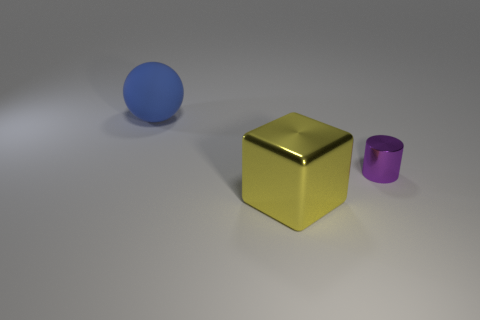What is the material of the big thing that is on the right side of the blue matte sphere?
Your answer should be very brief. Metal. There is a object that is behind the metallic cube and in front of the matte ball; what shape is it?
Your answer should be very brief. Cylinder. What material is the large yellow object?
Provide a succinct answer. Metal. What number of cylinders are either matte things or big red objects?
Offer a terse response. 0. Do the large yellow block and the blue thing have the same material?
Offer a very short reply. No. What is the thing that is both to the left of the tiny cylinder and in front of the large blue thing made of?
Ensure brevity in your answer.  Metal. Is the number of big spheres that are to the left of the tiny purple object the same as the number of tiny cylinders?
Your answer should be very brief. Yes. How many objects are objects that are behind the cube or objects?
Provide a short and direct response. 3. There is a large thing in front of the large blue ball; does it have the same color as the large rubber thing?
Give a very brief answer. No. What size is the purple thing that is behind the large yellow block?
Make the answer very short. Small. 